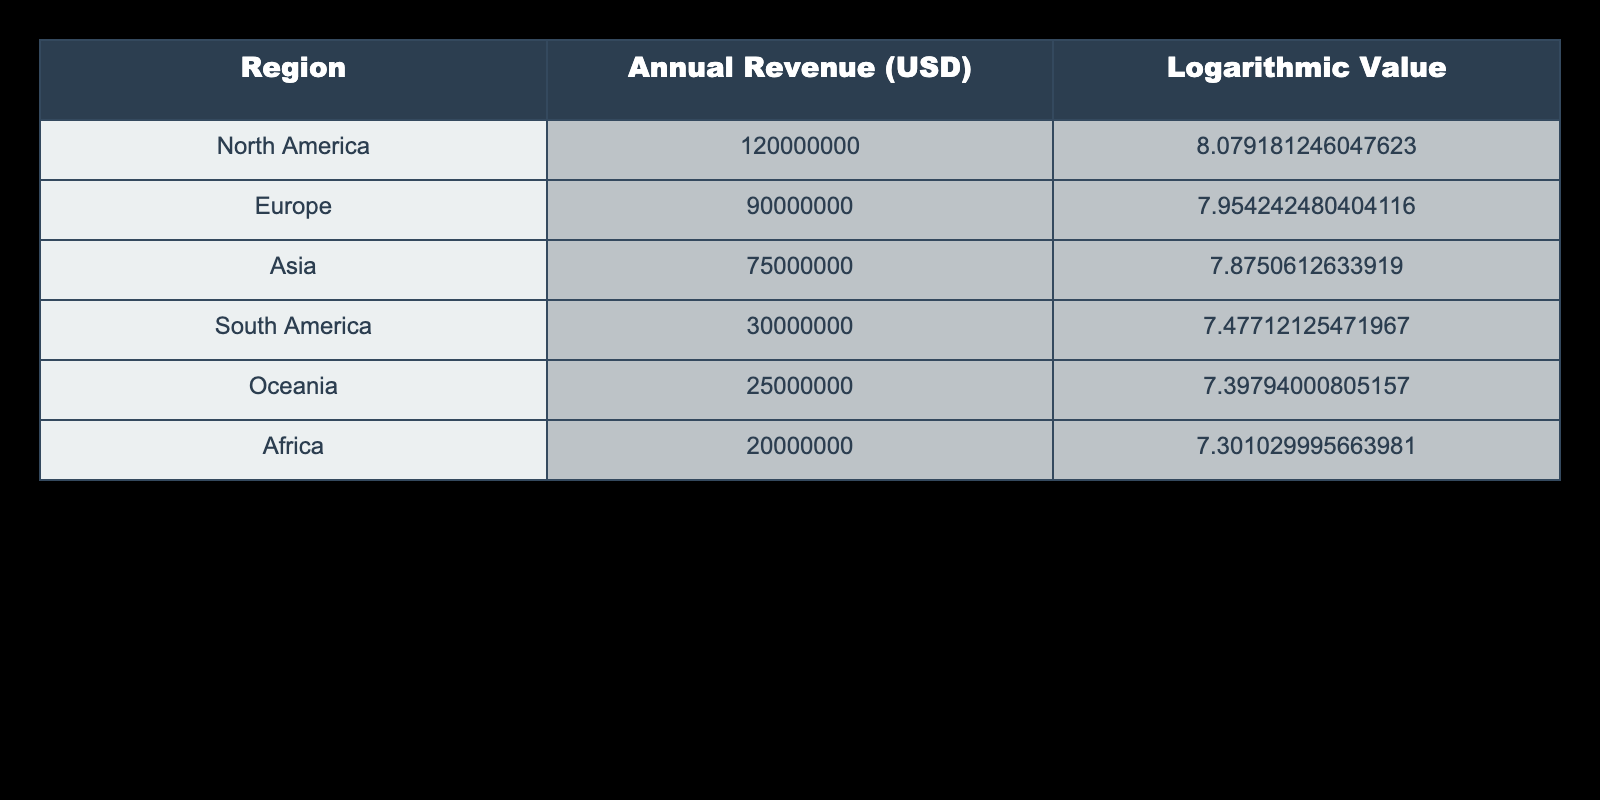What is the annual revenue from private art auctions in North America? The table shows that the annual revenue from private art auctions in North America is listed as 120,000,000 USD.
Answer: 120,000,000 USD Which region has the highest annual revenue from private art auctions? By comparing the annual revenue values, North America has the highest revenue at 120,000,000 USD, more than any other region.
Answer: North America If we combine the annual revenues of South America and Oceania, what is the total? The annual revenue for South America is 30,000,000 USD, and for Oceania, it is 25,000,000 USD. Adding these gives 30,000,000 + 25,000,000 = 55,000,000 USD.
Answer: 55,000,000 USD Is the logarithmic value of Africa's annual revenue greater than that of Oceania? The logarithmic value for Africa is 7.301, and for Oceania, it is 7.398. Since 7.301 is less than 7.398, it is false that Africa's logarithmic value is greater.
Answer: No What is the difference in logarithmic values between Europe and Asia? The logarithmic value for Europe is 7.954, and for Asia, it is 7.875. The difference is 7.954 - 7.875 = 0.079.
Answer: 0.079 What is the total annual revenue from all regions combined? Adding the annual revenues from all regions: 120,000,000 (North America) + 90,000,000 (Europe) + 75,000,000 (Asia) + 30,000,000 (South America) + 25,000,000 (Oceania) + 20,000,000 (Africa) results in a total of 360,000,000 USD.
Answer: 360,000,000 USD Which region has the lowest annual revenue from private art auctions, and what is that amount? By examining the table, Africa has the lowest annual revenue of 20,000,000 USD.
Answer: Africa, 20,000,000 USD Is the total annual revenue from Asia and Africa greater than that from North America? The annual revenue from Asia is 75,000,000 USD and from Africa is 20,000,000 USD, totaling 75,000,000 + 20,000,000 = 95,000,000 USD. North America's revenue is 120,000,000 USD, thus the total from Asia and Africa is less.
Answer: No How many regions have an annual revenue greater than 25,000,000 USD? The regions with greater annual revenues are North America (120,000,000), Europe (90,000,000), Asia (75,000,000), South America (30,000,000), which totals four regions above 25,000,000 USD.
Answer: 4 